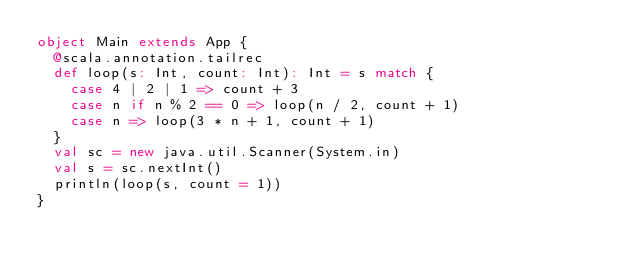<code> <loc_0><loc_0><loc_500><loc_500><_Scala_>object Main extends App {
  @scala.annotation.tailrec
  def loop(s: Int, count: Int): Int = s match {
    case 4 | 2 | 1 => count + 3
    case n if n % 2 == 0 => loop(n / 2, count + 1)
    case n => loop(3 * n + 1, count + 1)
  }
  val sc = new java.util.Scanner(System.in)
  val s = sc.nextInt()
  println(loop(s, count = 1))
}
</code> 